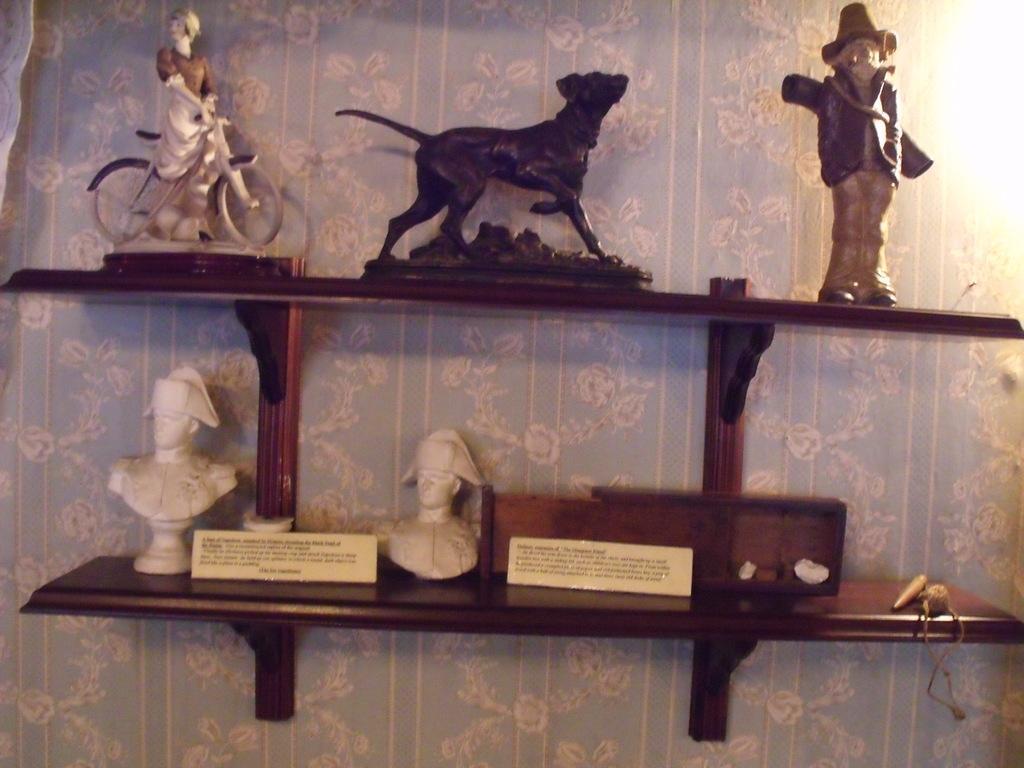Describe this image in one or two sentences. In the image there are small articles kept on a shelf that is fit to the wall. 